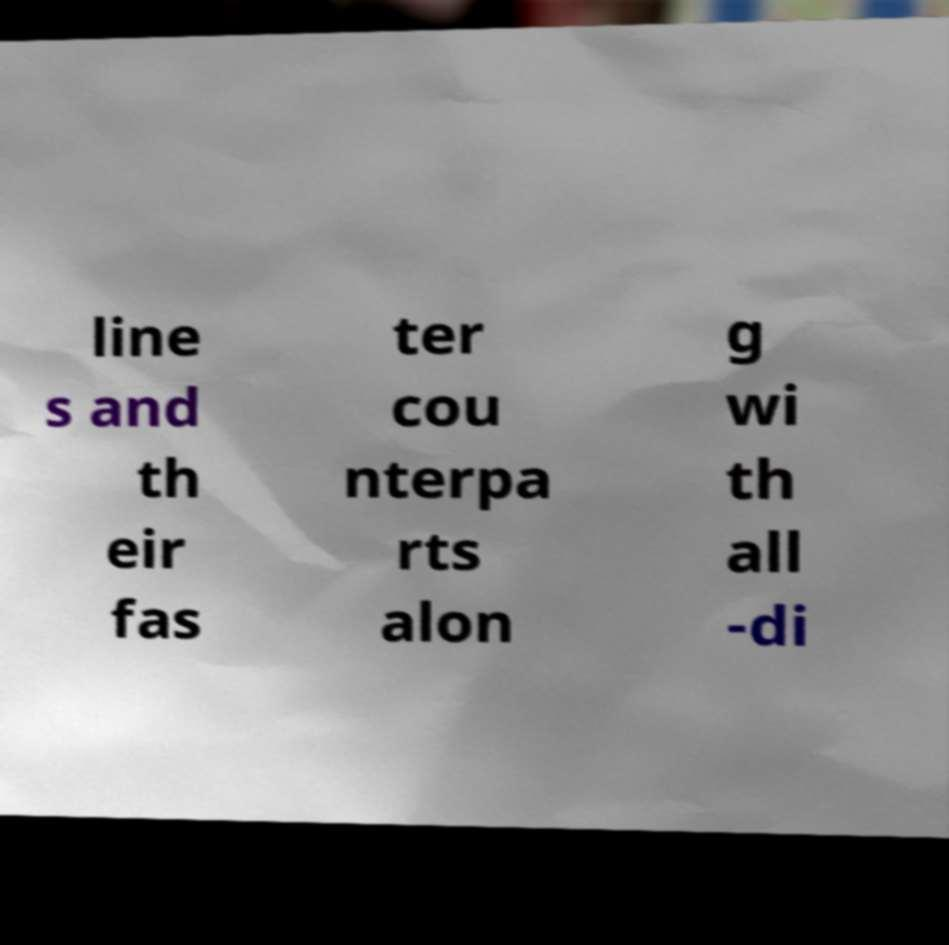Please read and relay the text visible in this image. What does it say? line s and th eir fas ter cou nterpa rts alon g wi th all -di 